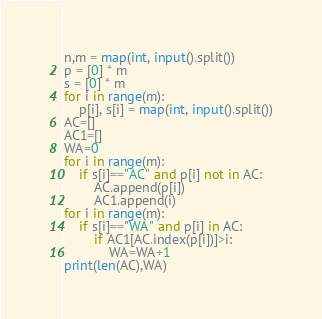<code> <loc_0><loc_0><loc_500><loc_500><_Python_>n,m = map(int, input().split())
p = [0] * m
s = [0] * m
for i in range(m):
    p[i], s[i] = map(int, input().split())
AC=[]
AC1=[]
WA=0
for i in range(m):
    if s[i]=="AC" and p[i] not in AC:
        AC.append(p[i])
        AC1.append(i)
for i in range(m):
    if s[i]=="WA" and p[i] in AC:
        if AC1[AC.index(p[i])]>i:
            WA=WA+1
print(len(AC),WA)</code> 